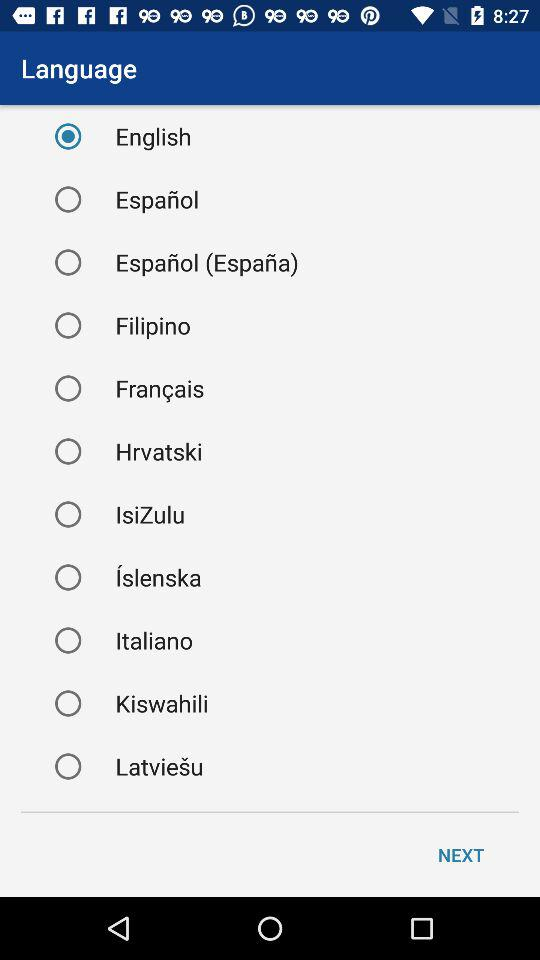What is the status of the Korean language?
When the provided information is insufficient, respond with <no answer>. <no answer> 